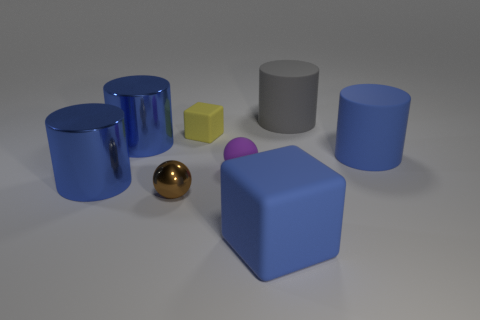How many blue cylinders must be subtracted to get 1 blue cylinders? 2 Subtract all red blocks. How many blue cylinders are left? 3 Subtract all green cylinders. Subtract all red cubes. How many cylinders are left? 4 Add 1 purple matte balls. How many objects exist? 9 Subtract all cubes. How many objects are left? 6 Subtract 0 yellow cylinders. How many objects are left? 8 Subtract all blue matte objects. Subtract all rubber blocks. How many objects are left? 4 Add 5 blue metal cylinders. How many blue metal cylinders are left? 7 Add 6 yellow rubber blocks. How many yellow rubber blocks exist? 7 